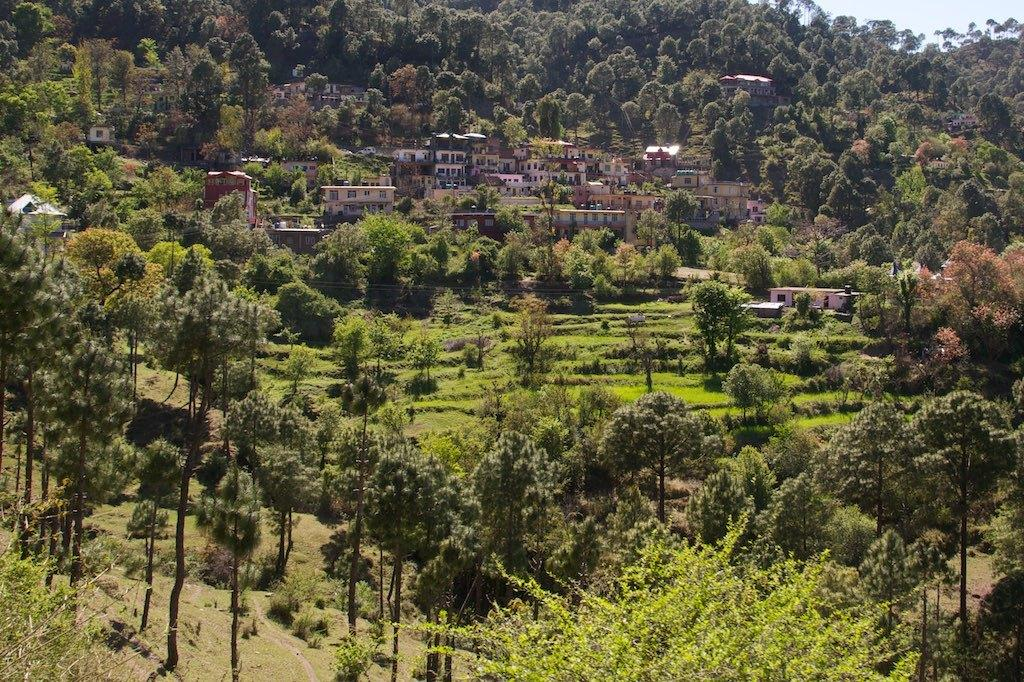What type of structures can be seen in the image? There are buildings in the image. What type of vegetation is present in the image? There are trees in the image. What type of ground cover is visible in the image? Grass is visible in the image. What part of the natural environment is visible in the image? The sky is visible in the top right corner of the image. What type of substance is being used to play with the ball in the image? There is no ball present in the image, so it is not possible to determine what substance might be used to play with it. 